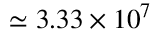Convert formula to latex. <formula><loc_0><loc_0><loc_500><loc_500>\simeq 3 . 3 3 \times 1 0 ^ { 7 }</formula> 